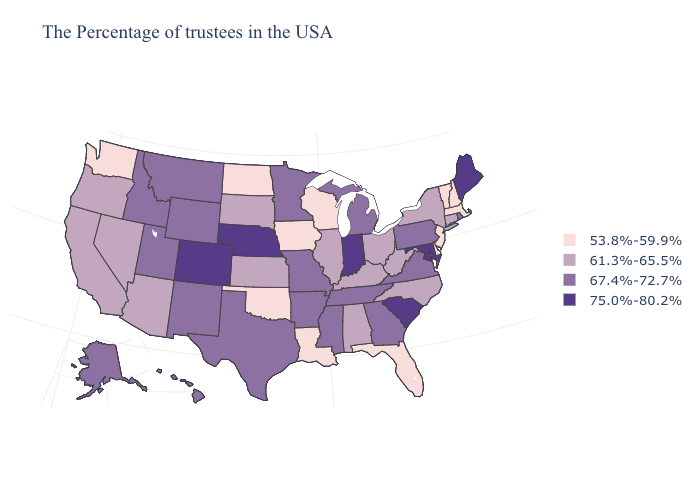Among the states that border Washington , which have the lowest value?
Concise answer only. Oregon. Among the states that border New York , does Pennsylvania have the highest value?
Be succinct. Yes. Does Kentucky have the lowest value in the South?
Concise answer only. No. Which states have the lowest value in the South?
Give a very brief answer. Delaware, Florida, Louisiana, Oklahoma. Name the states that have a value in the range 61.3%-65.5%?
Short answer required. Connecticut, New York, North Carolina, West Virginia, Ohio, Kentucky, Alabama, Illinois, Kansas, South Dakota, Arizona, Nevada, California, Oregon. Among the states that border Georgia , which have the highest value?
Short answer required. South Carolina. Name the states that have a value in the range 53.8%-59.9%?
Keep it brief. Massachusetts, New Hampshire, Vermont, New Jersey, Delaware, Florida, Wisconsin, Louisiana, Iowa, Oklahoma, North Dakota, Washington. Name the states that have a value in the range 61.3%-65.5%?
Answer briefly. Connecticut, New York, North Carolina, West Virginia, Ohio, Kentucky, Alabama, Illinois, Kansas, South Dakota, Arizona, Nevada, California, Oregon. Name the states that have a value in the range 61.3%-65.5%?
Keep it brief. Connecticut, New York, North Carolina, West Virginia, Ohio, Kentucky, Alabama, Illinois, Kansas, South Dakota, Arizona, Nevada, California, Oregon. What is the lowest value in the Northeast?
Be succinct. 53.8%-59.9%. Which states hav the highest value in the Northeast?
Quick response, please. Maine. Does the first symbol in the legend represent the smallest category?
Answer briefly. Yes. Name the states that have a value in the range 75.0%-80.2%?
Concise answer only. Maine, Maryland, South Carolina, Indiana, Nebraska, Colorado. What is the value of Nevada?
Quick response, please. 61.3%-65.5%. Does Florida have the lowest value in the USA?
Keep it brief. Yes. 